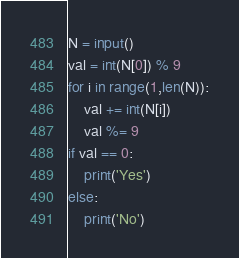Convert code to text. <code><loc_0><loc_0><loc_500><loc_500><_Python_>N = input()
val = int(N[0]) % 9
for i in range(1,len(N)):
    val += int(N[i])
    val %= 9
if val == 0:
    print('Yes')
else:
    print('No')
</code> 